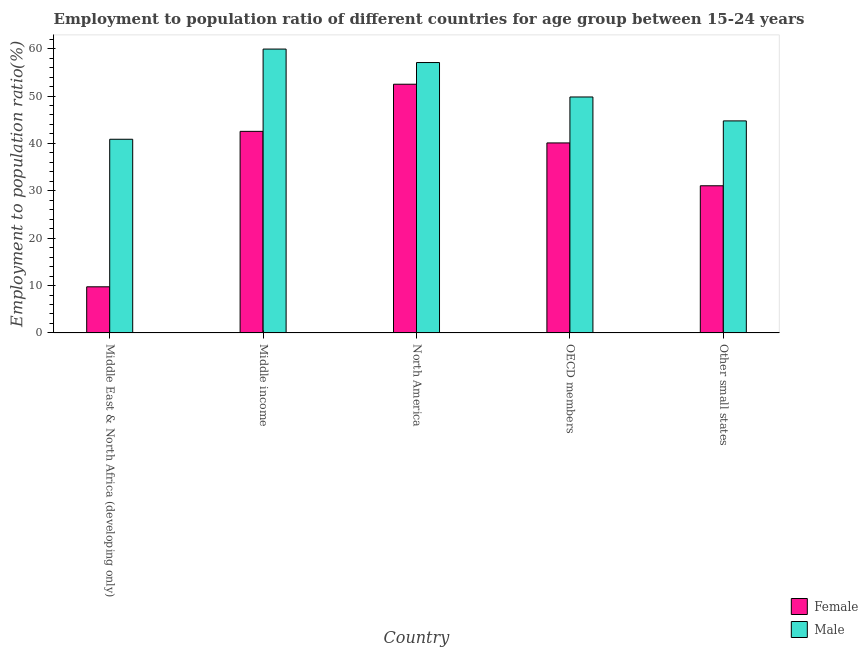How many different coloured bars are there?
Your answer should be compact. 2. Are the number of bars per tick equal to the number of legend labels?
Provide a succinct answer. Yes. Are the number of bars on each tick of the X-axis equal?
Your response must be concise. Yes. How many bars are there on the 1st tick from the left?
Offer a terse response. 2. What is the label of the 3rd group of bars from the left?
Your answer should be compact. North America. What is the employment to population ratio(female) in OECD members?
Provide a short and direct response. 40.1. Across all countries, what is the maximum employment to population ratio(female)?
Give a very brief answer. 52.49. Across all countries, what is the minimum employment to population ratio(female)?
Provide a succinct answer. 9.74. In which country was the employment to population ratio(male) maximum?
Provide a succinct answer. Middle income. In which country was the employment to population ratio(female) minimum?
Make the answer very short. Middle East & North Africa (developing only). What is the total employment to population ratio(male) in the graph?
Provide a short and direct response. 252.4. What is the difference between the employment to population ratio(male) in Middle East & North Africa (developing only) and that in OECD members?
Make the answer very short. -8.92. What is the difference between the employment to population ratio(female) in Middle income and the employment to population ratio(male) in North America?
Offer a terse response. -14.53. What is the average employment to population ratio(female) per country?
Provide a short and direct response. 35.19. What is the difference between the employment to population ratio(male) and employment to population ratio(female) in Other small states?
Offer a very short reply. 13.69. What is the ratio of the employment to population ratio(male) in Middle income to that in OECD members?
Provide a short and direct response. 1.2. Is the employment to population ratio(female) in Middle income less than that in Other small states?
Your answer should be very brief. No. Is the difference between the employment to population ratio(female) in OECD members and Other small states greater than the difference between the employment to population ratio(male) in OECD members and Other small states?
Give a very brief answer. Yes. What is the difference between the highest and the second highest employment to population ratio(male)?
Provide a short and direct response. 2.84. What is the difference between the highest and the lowest employment to population ratio(female)?
Provide a short and direct response. 42.75. In how many countries, is the employment to population ratio(male) greater than the average employment to population ratio(male) taken over all countries?
Your answer should be very brief. 2. Is the sum of the employment to population ratio(male) in Middle East & North Africa (developing only) and OECD members greater than the maximum employment to population ratio(female) across all countries?
Give a very brief answer. Yes. What does the 2nd bar from the right in Other small states represents?
Your response must be concise. Female. How many bars are there?
Keep it short and to the point. 10. How many countries are there in the graph?
Ensure brevity in your answer.  5. What is the difference between two consecutive major ticks on the Y-axis?
Your answer should be compact. 10. Are the values on the major ticks of Y-axis written in scientific E-notation?
Offer a very short reply. No. Does the graph contain any zero values?
Offer a very short reply. No. How many legend labels are there?
Offer a terse response. 2. How are the legend labels stacked?
Your response must be concise. Vertical. What is the title of the graph?
Give a very brief answer. Employment to population ratio of different countries for age group between 15-24 years. What is the label or title of the Y-axis?
Make the answer very short. Employment to population ratio(%). What is the Employment to population ratio(%) of Female in Middle East & North Africa (developing only)?
Ensure brevity in your answer.  9.74. What is the Employment to population ratio(%) in Male in Middle East & North Africa (developing only)?
Your response must be concise. 40.87. What is the Employment to population ratio(%) in Female in Middle income?
Your answer should be compact. 42.54. What is the Employment to population ratio(%) in Male in Middle income?
Your response must be concise. 59.91. What is the Employment to population ratio(%) of Female in North America?
Your answer should be very brief. 52.49. What is the Employment to population ratio(%) of Male in North America?
Offer a terse response. 57.07. What is the Employment to population ratio(%) in Female in OECD members?
Offer a terse response. 40.1. What is the Employment to population ratio(%) of Male in OECD members?
Your answer should be compact. 49.8. What is the Employment to population ratio(%) in Female in Other small states?
Offer a terse response. 31.06. What is the Employment to population ratio(%) in Male in Other small states?
Keep it short and to the point. 44.75. Across all countries, what is the maximum Employment to population ratio(%) of Female?
Your answer should be very brief. 52.49. Across all countries, what is the maximum Employment to population ratio(%) of Male?
Keep it short and to the point. 59.91. Across all countries, what is the minimum Employment to population ratio(%) of Female?
Make the answer very short. 9.74. Across all countries, what is the minimum Employment to population ratio(%) of Male?
Provide a succinct answer. 40.87. What is the total Employment to population ratio(%) of Female in the graph?
Give a very brief answer. 175.93. What is the total Employment to population ratio(%) in Male in the graph?
Give a very brief answer. 252.4. What is the difference between the Employment to population ratio(%) in Female in Middle East & North Africa (developing only) and that in Middle income?
Ensure brevity in your answer.  -32.81. What is the difference between the Employment to population ratio(%) in Male in Middle East & North Africa (developing only) and that in Middle income?
Your answer should be compact. -19.04. What is the difference between the Employment to population ratio(%) in Female in Middle East & North Africa (developing only) and that in North America?
Offer a terse response. -42.75. What is the difference between the Employment to population ratio(%) of Male in Middle East & North Africa (developing only) and that in North America?
Provide a succinct answer. -16.19. What is the difference between the Employment to population ratio(%) in Female in Middle East & North Africa (developing only) and that in OECD members?
Provide a short and direct response. -30.36. What is the difference between the Employment to population ratio(%) of Male in Middle East & North Africa (developing only) and that in OECD members?
Your answer should be compact. -8.92. What is the difference between the Employment to population ratio(%) in Female in Middle East & North Africa (developing only) and that in Other small states?
Offer a terse response. -21.32. What is the difference between the Employment to population ratio(%) of Male in Middle East & North Africa (developing only) and that in Other small states?
Provide a succinct answer. -3.87. What is the difference between the Employment to population ratio(%) of Female in Middle income and that in North America?
Offer a terse response. -9.95. What is the difference between the Employment to population ratio(%) in Male in Middle income and that in North America?
Your response must be concise. 2.84. What is the difference between the Employment to population ratio(%) in Female in Middle income and that in OECD members?
Your answer should be compact. 2.44. What is the difference between the Employment to population ratio(%) of Male in Middle income and that in OECD members?
Your answer should be very brief. 10.11. What is the difference between the Employment to population ratio(%) in Female in Middle income and that in Other small states?
Your response must be concise. 11.48. What is the difference between the Employment to population ratio(%) of Male in Middle income and that in Other small states?
Your answer should be compact. 15.16. What is the difference between the Employment to population ratio(%) in Female in North America and that in OECD members?
Offer a very short reply. 12.39. What is the difference between the Employment to population ratio(%) in Male in North America and that in OECD members?
Provide a succinct answer. 7.27. What is the difference between the Employment to population ratio(%) of Female in North America and that in Other small states?
Offer a very short reply. 21.43. What is the difference between the Employment to population ratio(%) in Male in North America and that in Other small states?
Make the answer very short. 12.32. What is the difference between the Employment to population ratio(%) in Female in OECD members and that in Other small states?
Keep it short and to the point. 9.04. What is the difference between the Employment to population ratio(%) in Male in OECD members and that in Other small states?
Your answer should be compact. 5.05. What is the difference between the Employment to population ratio(%) of Female in Middle East & North Africa (developing only) and the Employment to population ratio(%) of Male in Middle income?
Your answer should be compact. -50.17. What is the difference between the Employment to population ratio(%) of Female in Middle East & North Africa (developing only) and the Employment to population ratio(%) of Male in North America?
Offer a terse response. -47.33. What is the difference between the Employment to population ratio(%) in Female in Middle East & North Africa (developing only) and the Employment to population ratio(%) in Male in OECD members?
Your response must be concise. -40.06. What is the difference between the Employment to population ratio(%) in Female in Middle East & North Africa (developing only) and the Employment to population ratio(%) in Male in Other small states?
Make the answer very short. -35.01. What is the difference between the Employment to population ratio(%) of Female in Middle income and the Employment to population ratio(%) of Male in North America?
Ensure brevity in your answer.  -14.53. What is the difference between the Employment to population ratio(%) in Female in Middle income and the Employment to population ratio(%) in Male in OECD members?
Keep it short and to the point. -7.26. What is the difference between the Employment to population ratio(%) of Female in Middle income and the Employment to population ratio(%) of Male in Other small states?
Ensure brevity in your answer.  -2.21. What is the difference between the Employment to population ratio(%) in Female in North America and the Employment to population ratio(%) in Male in OECD members?
Ensure brevity in your answer.  2.69. What is the difference between the Employment to population ratio(%) of Female in North America and the Employment to population ratio(%) of Male in Other small states?
Provide a succinct answer. 7.74. What is the difference between the Employment to population ratio(%) of Female in OECD members and the Employment to population ratio(%) of Male in Other small states?
Provide a short and direct response. -4.65. What is the average Employment to population ratio(%) in Female per country?
Offer a very short reply. 35.19. What is the average Employment to population ratio(%) of Male per country?
Make the answer very short. 50.48. What is the difference between the Employment to population ratio(%) in Female and Employment to population ratio(%) in Male in Middle East & North Africa (developing only)?
Provide a short and direct response. -31.14. What is the difference between the Employment to population ratio(%) in Female and Employment to population ratio(%) in Male in Middle income?
Offer a very short reply. -17.37. What is the difference between the Employment to population ratio(%) in Female and Employment to population ratio(%) in Male in North America?
Your answer should be compact. -4.58. What is the difference between the Employment to population ratio(%) of Female and Employment to population ratio(%) of Male in OECD members?
Keep it short and to the point. -9.7. What is the difference between the Employment to population ratio(%) in Female and Employment to population ratio(%) in Male in Other small states?
Offer a terse response. -13.69. What is the ratio of the Employment to population ratio(%) of Female in Middle East & North Africa (developing only) to that in Middle income?
Keep it short and to the point. 0.23. What is the ratio of the Employment to population ratio(%) of Male in Middle East & North Africa (developing only) to that in Middle income?
Provide a succinct answer. 0.68. What is the ratio of the Employment to population ratio(%) in Female in Middle East & North Africa (developing only) to that in North America?
Ensure brevity in your answer.  0.19. What is the ratio of the Employment to population ratio(%) in Male in Middle East & North Africa (developing only) to that in North America?
Offer a terse response. 0.72. What is the ratio of the Employment to population ratio(%) in Female in Middle East & North Africa (developing only) to that in OECD members?
Your answer should be very brief. 0.24. What is the ratio of the Employment to population ratio(%) of Male in Middle East & North Africa (developing only) to that in OECD members?
Your response must be concise. 0.82. What is the ratio of the Employment to population ratio(%) of Female in Middle East & North Africa (developing only) to that in Other small states?
Your response must be concise. 0.31. What is the ratio of the Employment to population ratio(%) of Male in Middle East & North Africa (developing only) to that in Other small states?
Keep it short and to the point. 0.91. What is the ratio of the Employment to population ratio(%) in Female in Middle income to that in North America?
Make the answer very short. 0.81. What is the ratio of the Employment to population ratio(%) in Male in Middle income to that in North America?
Keep it short and to the point. 1.05. What is the ratio of the Employment to population ratio(%) of Female in Middle income to that in OECD members?
Provide a short and direct response. 1.06. What is the ratio of the Employment to population ratio(%) in Male in Middle income to that in OECD members?
Make the answer very short. 1.2. What is the ratio of the Employment to population ratio(%) of Female in Middle income to that in Other small states?
Offer a terse response. 1.37. What is the ratio of the Employment to population ratio(%) in Male in Middle income to that in Other small states?
Your response must be concise. 1.34. What is the ratio of the Employment to population ratio(%) of Female in North America to that in OECD members?
Provide a succinct answer. 1.31. What is the ratio of the Employment to population ratio(%) of Male in North America to that in OECD members?
Make the answer very short. 1.15. What is the ratio of the Employment to population ratio(%) in Female in North America to that in Other small states?
Your answer should be compact. 1.69. What is the ratio of the Employment to population ratio(%) in Male in North America to that in Other small states?
Ensure brevity in your answer.  1.28. What is the ratio of the Employment to population ratio(%) of Female in OECD members to that in Other small states?
Provide a succinct answer. 1.29. What is the ratio of the Employment to population ratio(%) of Male in OECD members to that in Other small states?
Keep it short and to the point. 1.11. What is the difference between the highest and the second highest Employment to population ratio(%) of Female?
Offer a terse response. 9.95. What is the difference between the highest and the second highest Employment to population ratio(%) of Male?
Your answer should be compact. 2.84. What is the difference between the highest and the lowest Employment to population ratio(%) in Female?
Make the answer very short. 42.75. What is the difference between the highest and the lowest Employment to population ratio(%) of Male?
Your answer should be compact. 19.04. 